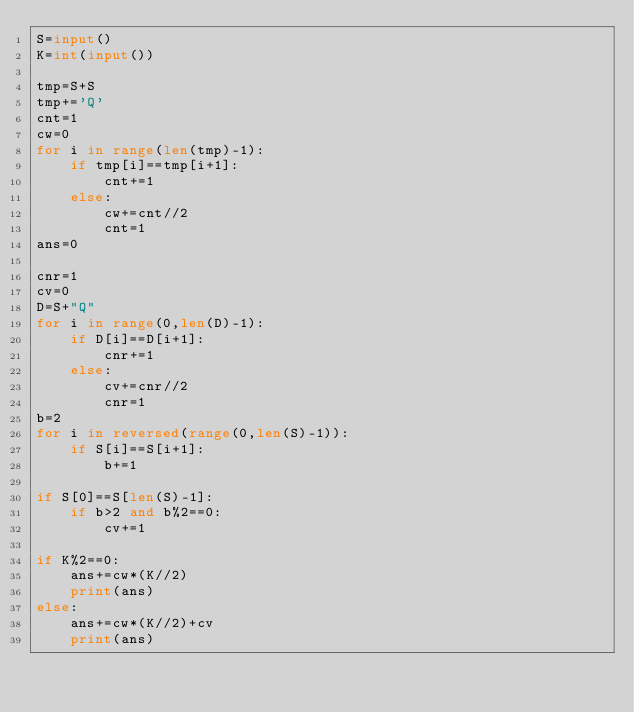<code> <loc_0><loc_0><loc_500><loc_500><_Python_>S=input()
K=int(input())

tmp=S+S
tmp+='Q'
cnt=1
cw=0
for i in range(len(tmp)-1):
    if tmp[i]==tmp[i+1]:
        cnt+=1
    else:
        cw+=cnt//2
        cnt=1
ans=0

cnr=1
cv=0
D=S+"Q"
for i in range(0,len(D)-1):
    if D[i]==D[i+1]:
        cnr+=1
    else:
        cv+=cnr//2
        cnr=1
b=2
for i in reversed(range(0,len(S)-1)):
    if S[i]==S[i+1]:
        b+=1

if S[0]==S[len(S)-1]:
    if b>2 and b%2==0:
        cv+=1

if K%2==0:
    ans+=cw*(K//2)
    print(ans)
else:
    ans+=cw*(K//2)+cv
    print(ans)</code> 